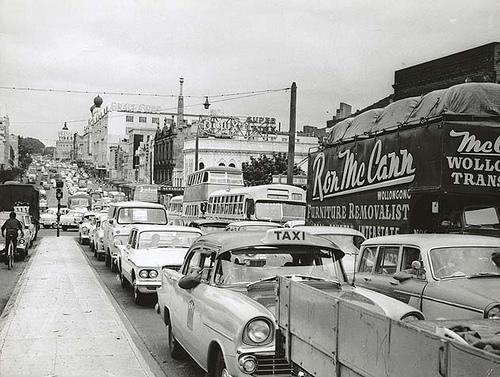How many trucks are there?
Give a very brief answer. 2. How many buses can you see?
Give a very brief answer. 2. How many cars can you see?
Give a very brief answer. 5. 